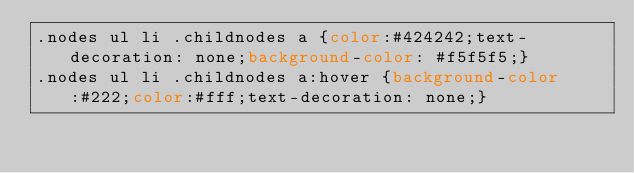Convert code to text. <code><loc_0><loc_0><loc_500><loc_500><_CSS_>.nodes ul li .childnodes a {color:#424242;text-decoration: none;background-color: #f5f5f5;}
.nodes ul li .childnodes a:hover {background-color:#222;color:#fff;text-decoration: none;}
</code> 